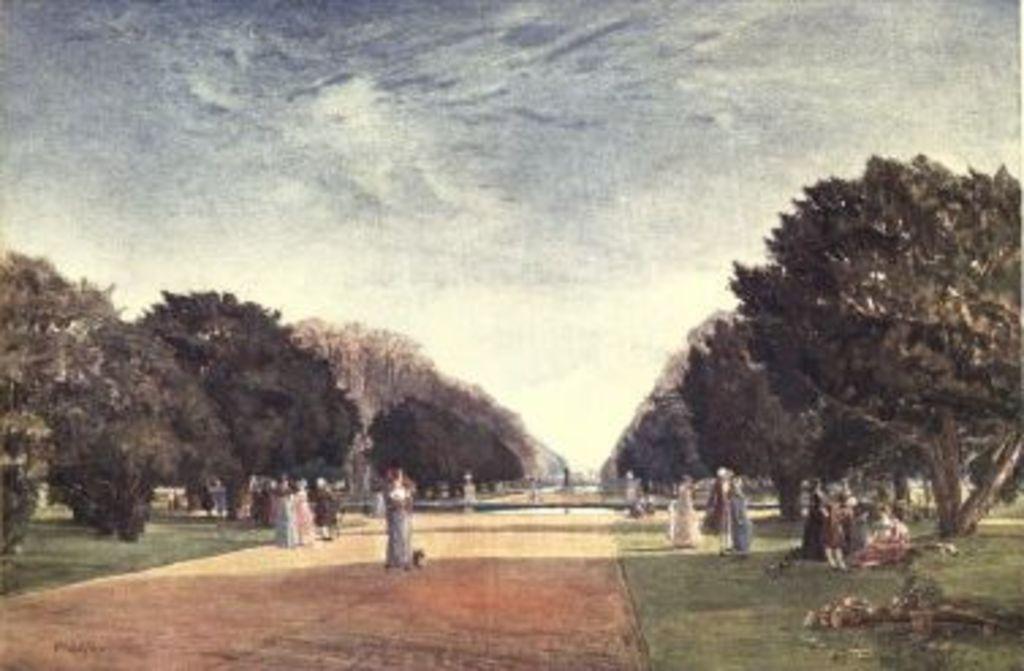Can you describe this image briefly? This is a painting where we can see trees, people, grassy land, road and the sky. 